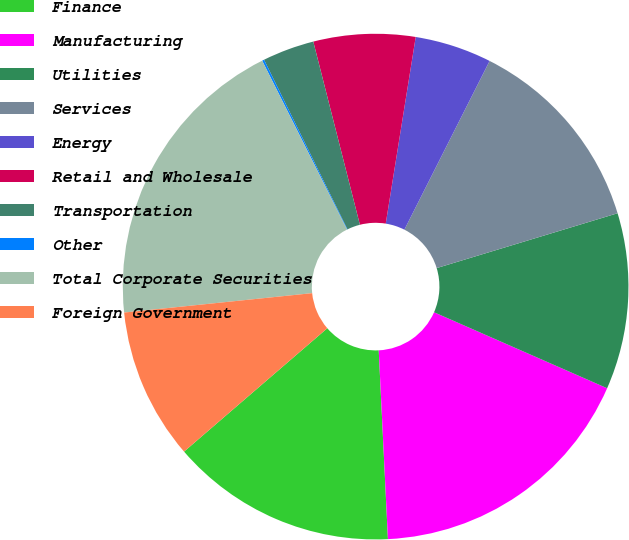Convert chart. <chart><loc_0><loc_0><loc_500><loc_500><pie_chart><fcel>Finance<fcel>Manufacturing<fcel>Utilities<fcel>Services<fcel>Energy<fcel>Retail and Wholesale<fcel>Transportation<fcel>Other<fcel>Total Corporate Securities<fcel>Foreign Government<nl><fcel>14.46%<fcel>17.64%<fcel>11.27%<fcel>12.87%<fcel>4.91%<fcel>6.5%<fcel>3.31%<fcel>0.13%<fcel>19.23%<fcel>9.68%<nl></chart> 